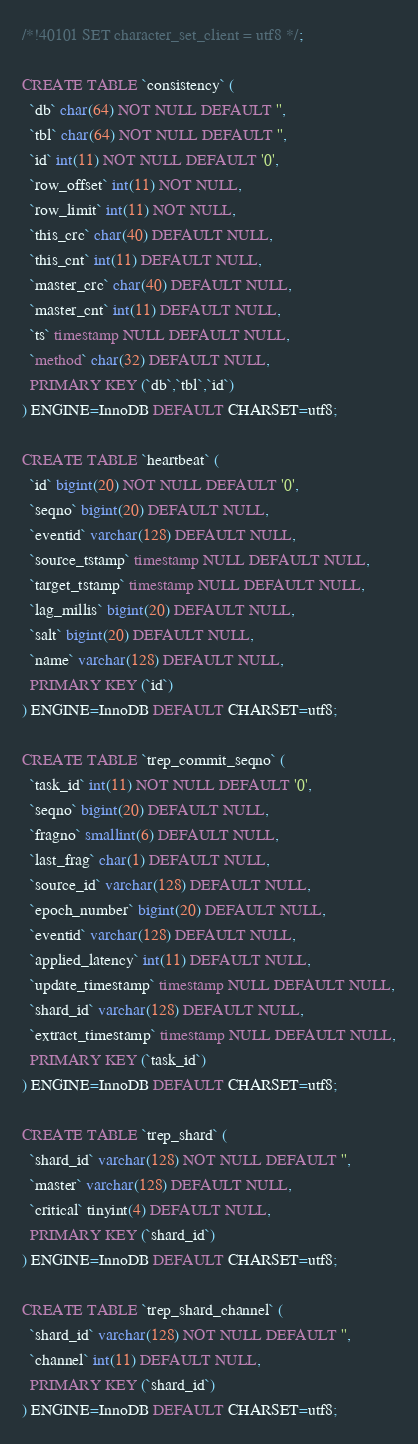<code> <loc_0><loc_0><loc_500><loc_500><_SQL_>/*!40101 SET character_set_client = utf8 */;

CREATE TABLE `consistency` (
  `db` char(64) NOT NULL DEFAULT '',
  `tbl` char(64) NOT NULL DEFAULT '',
  `id` int(11) NOT NULL DEFAULT '0',
  `row_offset` int(11) NOT NULL,
  `row_limit` int(11) NOT NULL,
  `this_crc` char(40) DEFAULT NULL,
  `this_cnt` int(11) DEFAULT NULL,
  `master_crc` char(40) DEFAULT NULL,
  `master_cnt` int(11) DEFAULT NULL,
  `ts` timestamp NULL DEFAULT NULL,
  `method` char(32) DEFAULT NULL,
  PRIMARY KEY (`db`,`tbl`,`id`)
) ENGINE=InnoDB DEFAULT CHARSET=utf8;

CREATE TABLE `heartbeat` (
  `id` bigint(20) NOT NULL DEFAULT '0',
  `seqno` bigint(20) DEFAULT NULL,
  `eventid` varchar(128) DEFAULT NULL,
  `source_tstamp` timestamp NULL DEFAULT NULL,
  `target_tstamp` timestamp NULL DEFAULT NULL,
  `lag_millis` bigint(20) DEFAULT NULL,
  `salt` bigint(20) DEFAULT NULL,
  `name` varchar(128) DEFAULT NULL,
  PRIMARY KEY (`id`)
) ENGINE=InnoDB DEFAULT CHARSET=utf8;

CREATE TABLE `trep_commit_seqno` (
  `task_id` int(11) NOT NULL DEFAULT '0',
  `seqno` bigint(20) DEFAULT NULL,
  `fragno` smallint(6) DEFAULT NULL,
  `last_frag` char(1) DEFAULT NULL,
  `source_id` varchar(128) DEFAULT NULL,
  `epoch_number` bigint(20) DEFAULT NULL,
  `eventid` varchar(128) DEFAULT NULL,
  `applied_latency` int(11) DEFAULT NULL,
  `update_timestamp` timestamp NULL DEFAULT NULL,
  `shard_id` varchar(128) DEFAULT NULL,
  `extract_timestamp` timestamp NULL DEFAULT NULL,
  PRIMARY KEY (`task_id`)
) ENGINE=InnoDB DEFAULT CHARSET=utf8;

CREATE TABLE `trep_shard` (
  `shard_id` varchar(128) NOT NULL DEFAULT '',
  `master` varchar(128) DEFAULT NULL,
  `critical` tinyint(4) DEFAULT NULL,
  PRIMARY KEY (`shard_id`)
) ENGINE=InnoDB DEFAULT CHARSET=utf8;

CREATE TABLE `trep_shard_channel` (
  `shard_id` varchar(128) NOT NULL DEFAULT '',
  `channel` int(11) DEFAULT NULL,
  PRIMARY KEY (`shard_id`)
) ENGINE=InnoDB DEFAULT CHARSET=utf8;</code> 